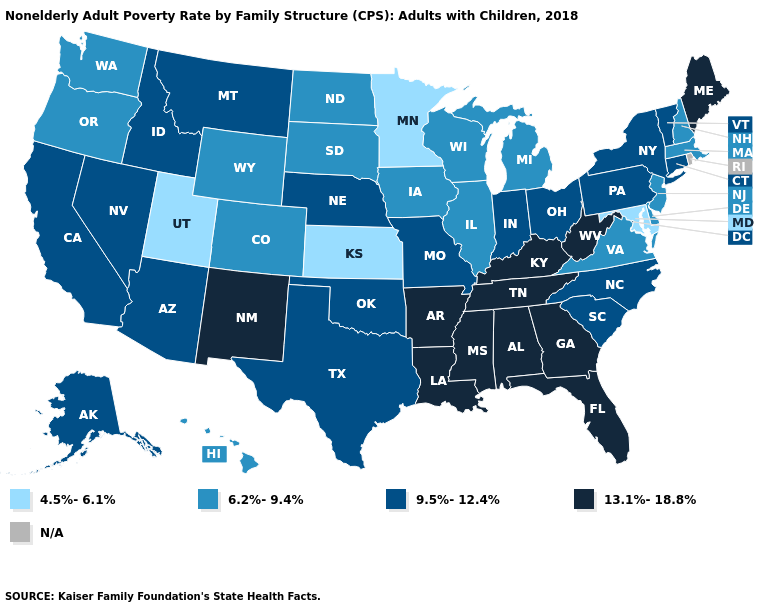Among the states that border Wisconsin , which have the lowest value?
Quick response, please. Minnesota. Name the states that have a value in the range 13.1%-18.8%?
Keep it brief. Alabama, Arkansas, Florida, Georgia, Kentucky, Louisiana, Maine, Mississippi, New Mexico, Tennessee, West Virginia. Among the states that border Nevada , does Oregon have the lowest value?
Be succinct. No. Which states have the lowest value in the USA?
Be succinct. Kansas, Maryland, Minnesota, Utah. Does Pennsylvania have the lowest value in the Northeast?
Short answer required. No. Among the states that border Colorado , does New Mexico have the highest value?
Quick response, please. Yes. What is the lowest value in the USA?
Write a very short answer. 4.5%-6.1%. Among the states that border Illinois , does Wisconsin have the lowest value?
Quick response, please. Yes. Which states have the lowest value in the MidWest?
Keep it brief. Kansas, Minnesota. Among the states that border Georgia , does Florida have the highest value?
Keep it brief. Yes. What is the highest value in the USA?
Concise answer only. 13.1%-18.8%. What is the highest value in the USA?
Quick response, please. 13.1%-18.8%. What is the highest value in the South ?
Short answer required. 13.1%-18.8%. 